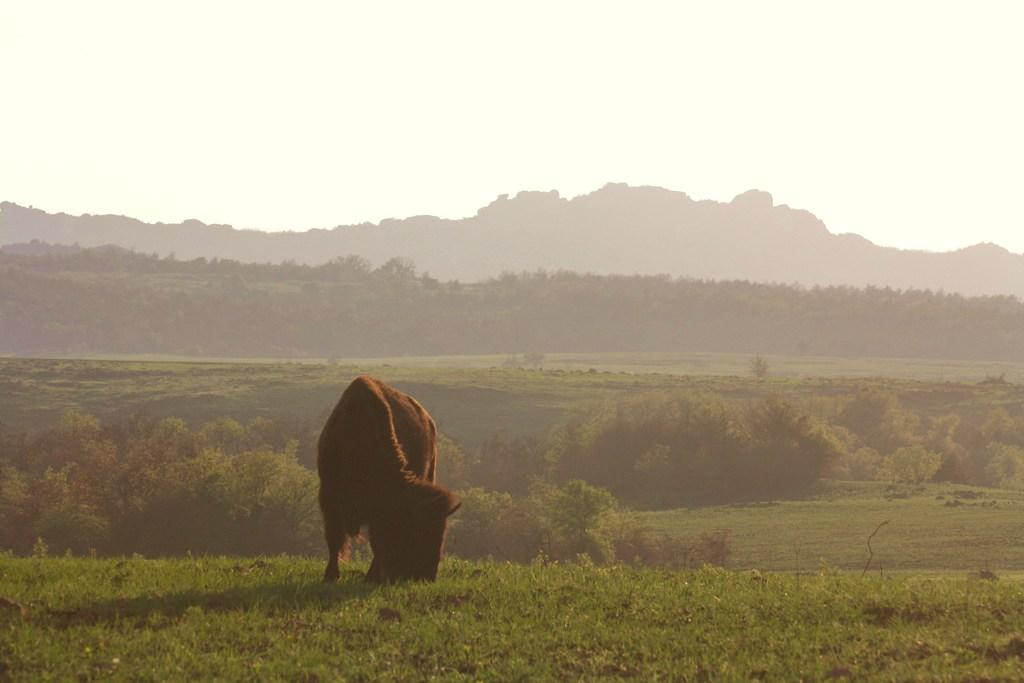What animal is the main subject of the image? There is a bison in the image. What is the bison doing in the image? The bison is eating grass. What can be seen in the background of the image? There are trees, mountains, and the sky visible in the background of the image. What is the purpose of the hen in the image? There is no hen present in the image; it features a bison eating grass. Can you describe the yard where the bison is grazing in the image? There is no yard mentioned in the image; it only shows a bison eating grass in a natural environment with trees, mountains, and the sky in the background. 